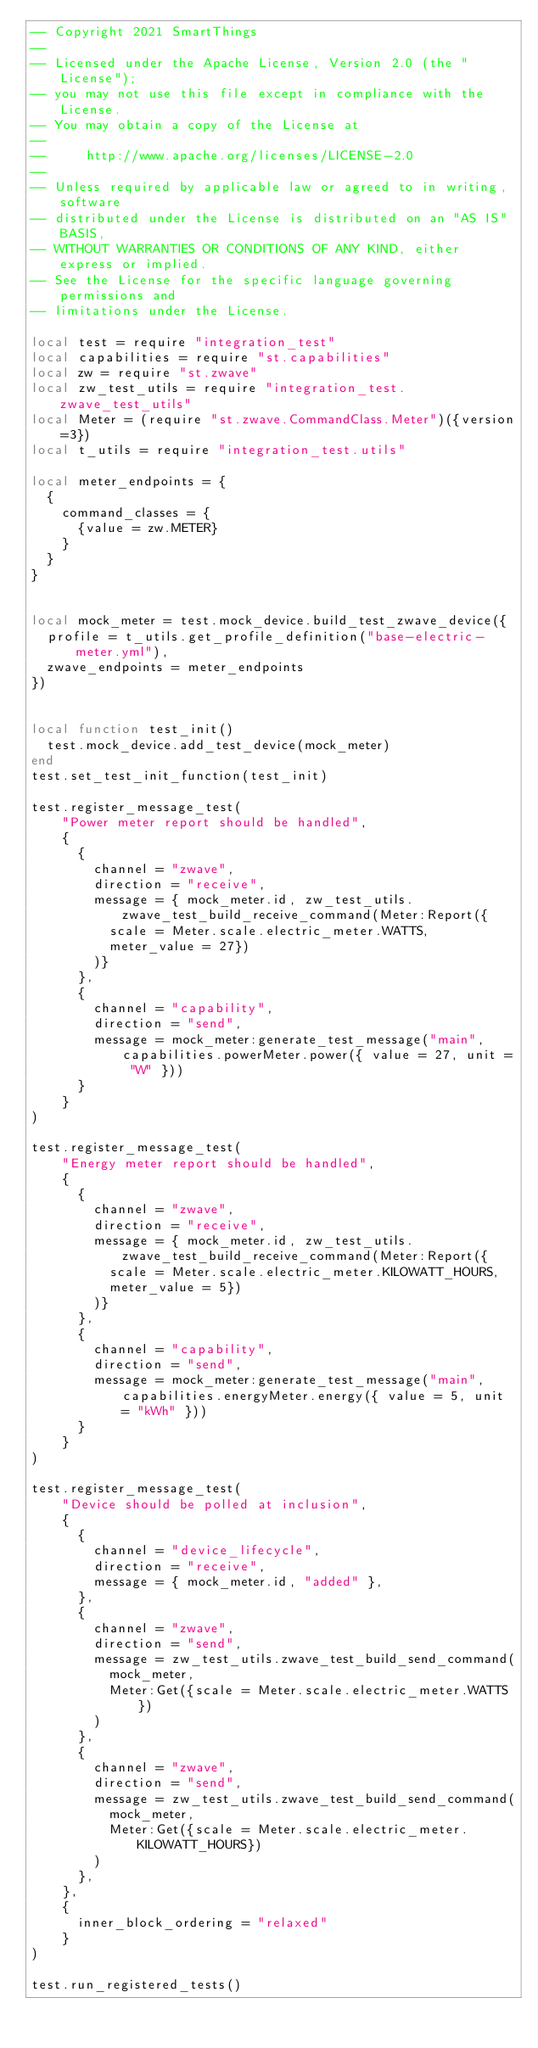Convert code to text. <code><loc_0><loc_0><loc_500><loc_500><_Lua_>-- Copyright 2021 SmartThings
--
-- Licensed under the Apache License, Version 2.0 (the "License");
-- you may not use this file except in compliance with the License.
-- You may obtain a copy of the License at
--
--     http://www.apache.org/licenses/LICENSE-2.0
--
-- Unless required by applicable law or agreed to in writing, software
-- distributed under the License is distributed on an "AS IS" BASIS,
-- WITHOUT WARRANTIES OR CONDITIONS OF ANY KIND, either express or implied.
-- See the License for the specific language governing permissions and
-- limitations under the License.

local test = require "integration_test"
local capabilities = require "st.capabilities"
local zw = require "st.zwave"
local zw_test_utils = require "integration_test.zwave_test_utils"
local Meter = (require "st.zwave.CommandClass.Meter")({version=3})
local t_utils = require "integration_test.utils"

local meter_endpoints = {
  {
    command_classes = {
      {value = zw.METER}
    }
  }
}


local mock_meter = test.mock_device.build_test_zwave_device({
  profile = t_utils.get_profile_definition("base-electric-meter.yml"),
  zwave_endpoints = meter_endpoints
})


local function test_init()
  test.mock_device.add_test_device(mock_meter)
end
test.set_test_init_function(test_init)

test.register_message_test(
    "Power meter report should be handled",
    {
      {
        channel = "zwave",
        direction = "receive",
        message = { mock_meter.id, zw_test_utils.zwave_test_build_receive_command(Meter:Report({
          scale = Meter.scale.electric_meter.WATTS,
          meter_value = 27})
        )}
      },
      {
        channel = "capability",
        direction = "send",
        message = mock_meter:generate_test_message("main", capabilities.powerMeter.power({ value = 27, unit = "W" }))
      }
    }
)

test.register_message_test(
    "Energy meter report should be handled",
    {
      {
        channel = "zwave",
        direction = "receive",
        message = { mock_meter.id, zw_test_utils.zwave_test_build_receive_command(Meter:Report({
          scale = Meter.scale.electric_meter.KILOWATT_HOURS,
          meter_value = 5})
        )}
      },
      {
        channel = "capability",
        direction = "send",
        message = mock_meter:generate_test_message("main", capabilities.energyMeter.energy({ value = 5, unit = "kWh" }))
      }
    }
)

test.register_message_test(
    "Device should be polled at inclusion",
    {
      {
        channel = "device_lifecycle",
        direction = "receive",
        message = { mock_meter.id, "added" },
      },
      {
        channel = "zwave",
        direction = "send",
        message = zw_test_utils.zwave_test_build_send_command(
          mock_meter,
          Meter:Get({scale = Meter.scale.electric_meter.WATTS})
        )
      },
      {
        channel = "zwave",
        direction = "send",
        message = zw_test_utils.zwave_test_build_send_command(
          mock_meter,
          Meter:Get({scale = Meter.scale.electric_meter.KILOWATT_HOURS})
        )
      },
    },
    {
      inner_block_ordering = "relaxed"
    }
)

test.run_registered_tests()
</code> 